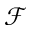Convert formula to latex. <formula><loc_0><loc_0><loc_500><loc_500>\mathcal { F }</formula> 